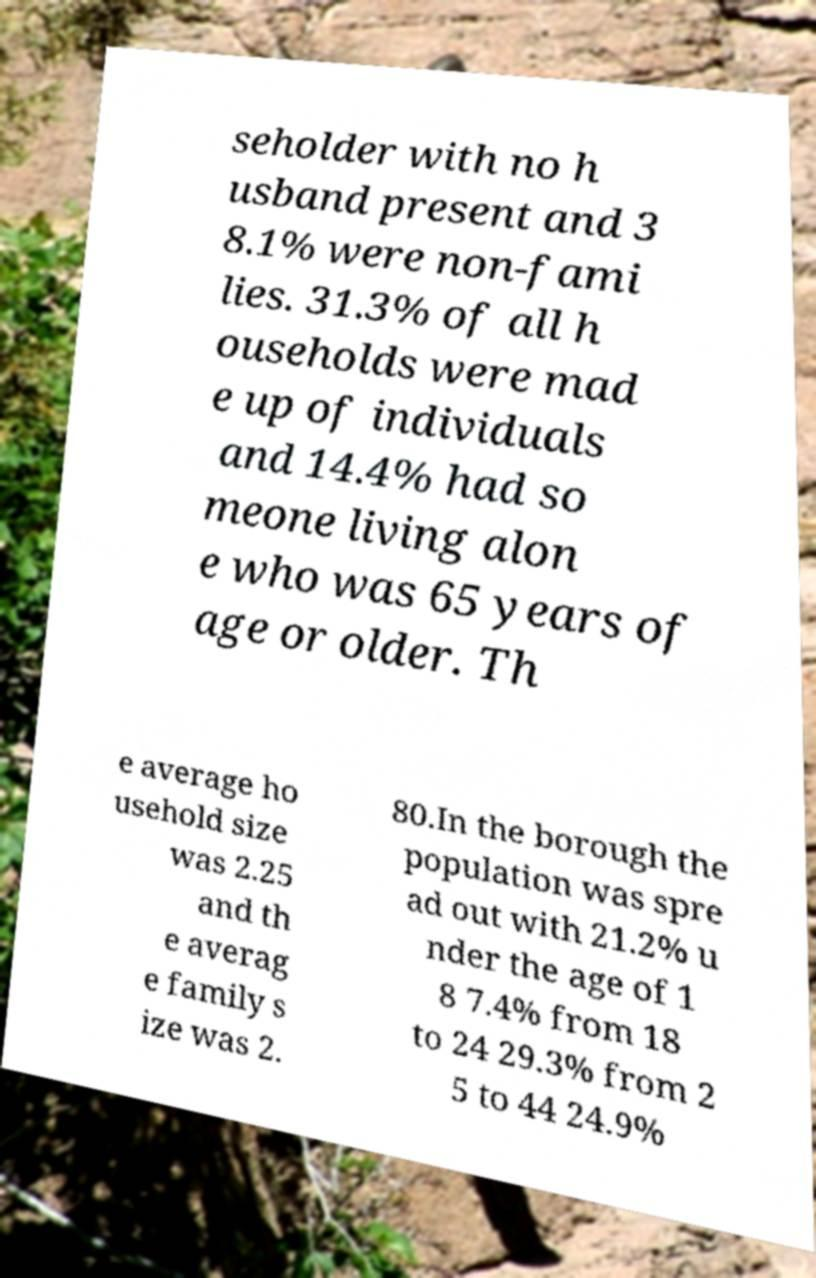Please read and relay the text visible in this image. What does it say? seholder with no h usband present and 3 8.1% were non-fami lies. 31.3% of all h ouseholds were mad e up of individuals and 14.4% had so meone living alon e who was 65 years of age or older. Th e average ho usehold size was 2.25 and th e averag e family s ize was 2. 80.In the borough the population was spre ad out with 21.2% u nder the age of 1 8 7.4% from 18 to 24 29.3% from 2 5 to 44 24.9% 